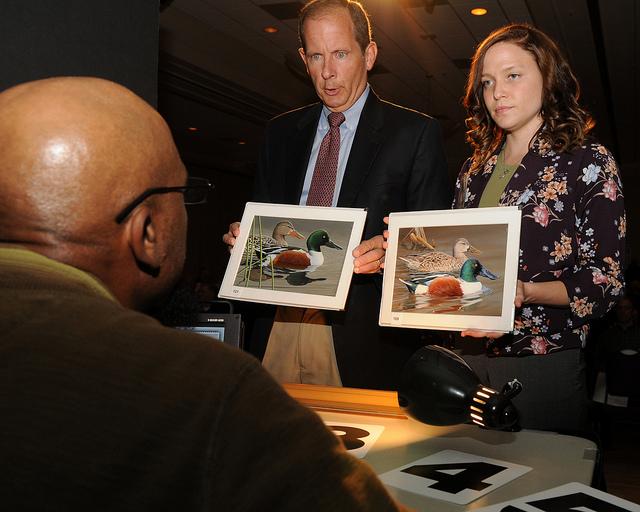What is the print on the woman's shirt?
Answer briefly. Flowers. What is in the pictures being displayed?
Answer briefly. Ducks. Are these pictures being judged with number scores?
Short answer required. Yes. 